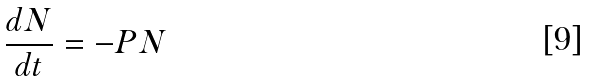Convert formula to latex. <formula><loc_0><loc_0><loc_500><loc_500>\frac { d N } { d t } = - P N</formula> 